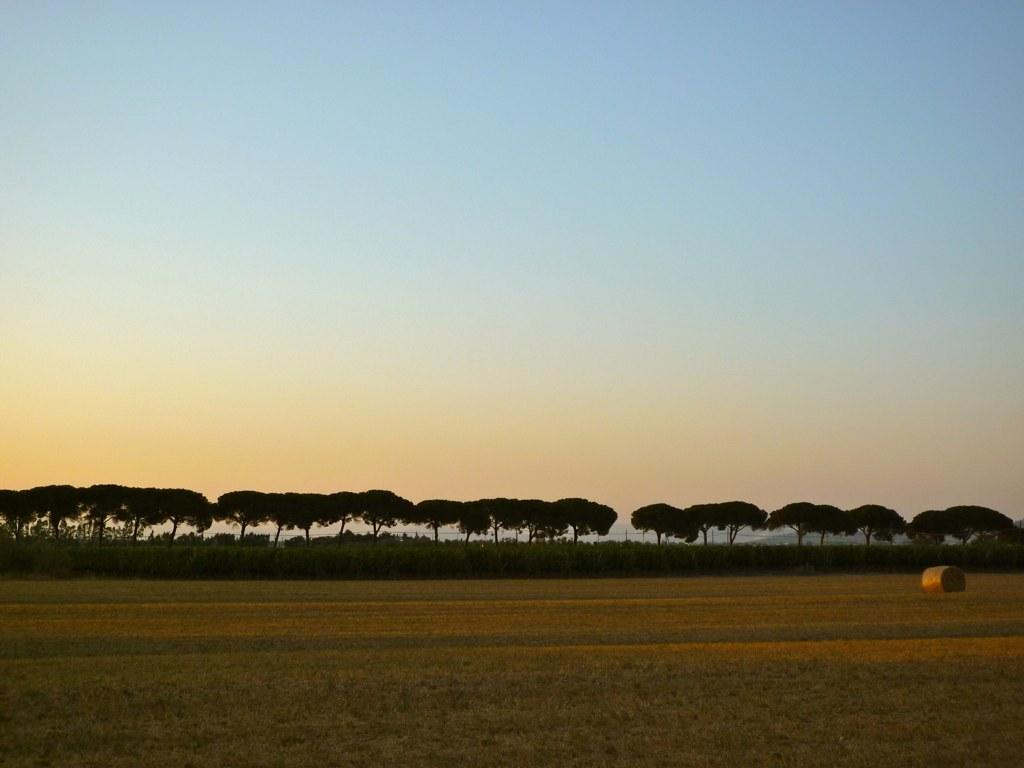What can be seen on the ground in the image? There is an object on the ground in the image. What type of vegetation is present in the image? There are trees in the image, and they are green in color. What is visible in the background of the image? The sky is visible in the background of the image. Can you see the cloth being blown by the zephyr in the image? There is no cloth or zephyr present in the image. How many times does the object on the ground jump in the image? The object on the ground does not jump in the image; it is stationary. 